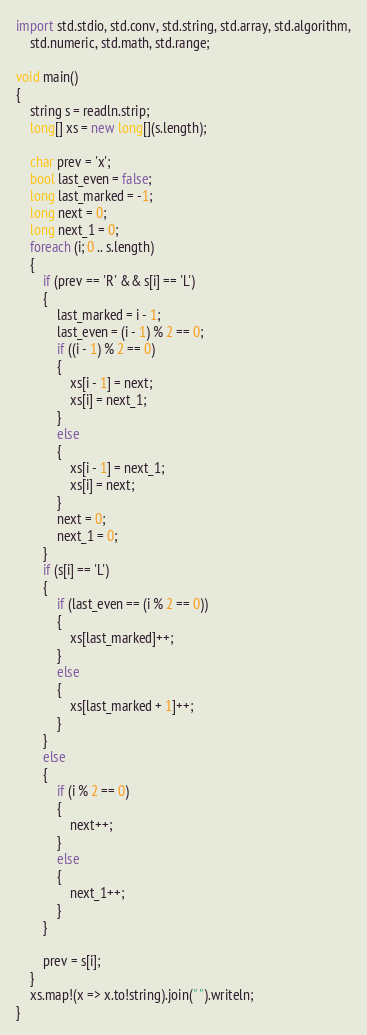Convert code to text. <code><loc_0><loc_0><loc_500><loc_500><_D_>import std.stdio, std.conv, std.string, std.array, std.algorithm,
    std.numeric, std.math, std.range;

void main()
{
    string s = readln.strip;
    long[] xs = new long[](s.length);

    char prev = 'x';
    bool last_even = false;
    long last_marked = -1;
    long next = 0;
    long next_1 = 0;
    foreach (i; 0 .. s.length)
    {
        if (prev == 'R' && s[i] == 'L')
        {
            last_marked = i - 1;
            last_even = (i - 1) % 2 == 0;
            if ((i - 1) % 2 == 0)
            {
                xs[i - 1] = next;
                xs[i] = next_1;
            }
            else
            {
                xs[i - 1] = next_1;
                xs[i] = next;
            }
            next = 0;
            next_1 = 0;
        }
        if (s[i] == 'L')
        {
            if (last_even == (i % 2 == 0))
            {
                xs[last_marked]++;
            }
            else
            {
                xs[last_marked + 1]++;
            }
        }
        else
        {
            if (i % 2 == 0)
            {
                next++;
            }
            else
            {
                next_1++;
            }
        }

        prev = s[i];
    }
    xs.map!(x => x.to!string).join(" ").writeln;
}
</code> 